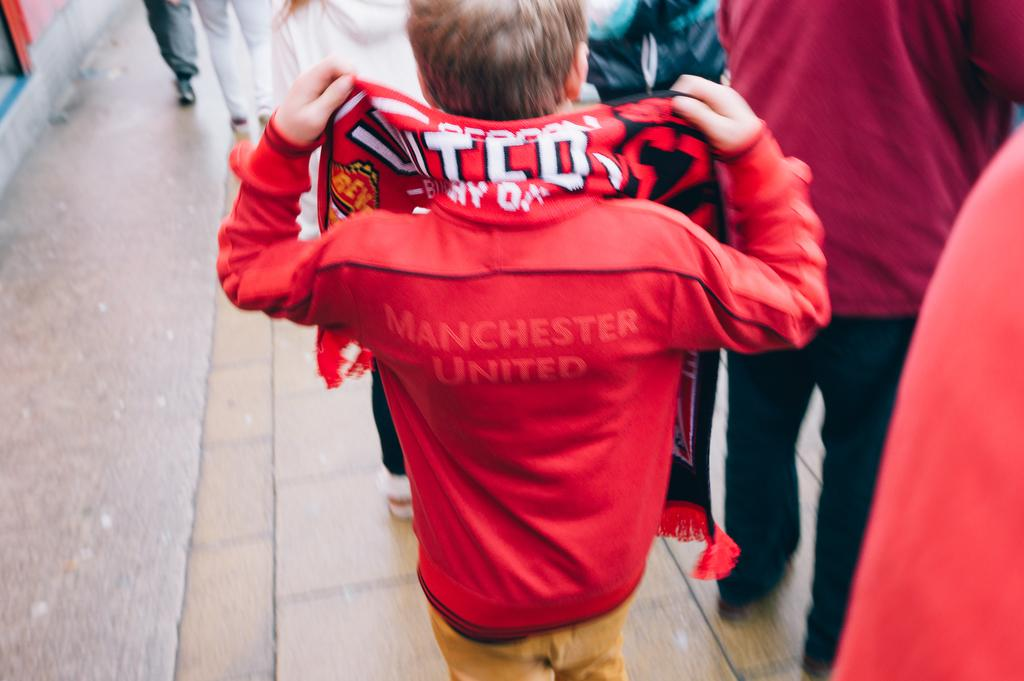<image>
Share a concise interpretation of the image provided. Manchester United is printed on the back of this sport's jacket. 